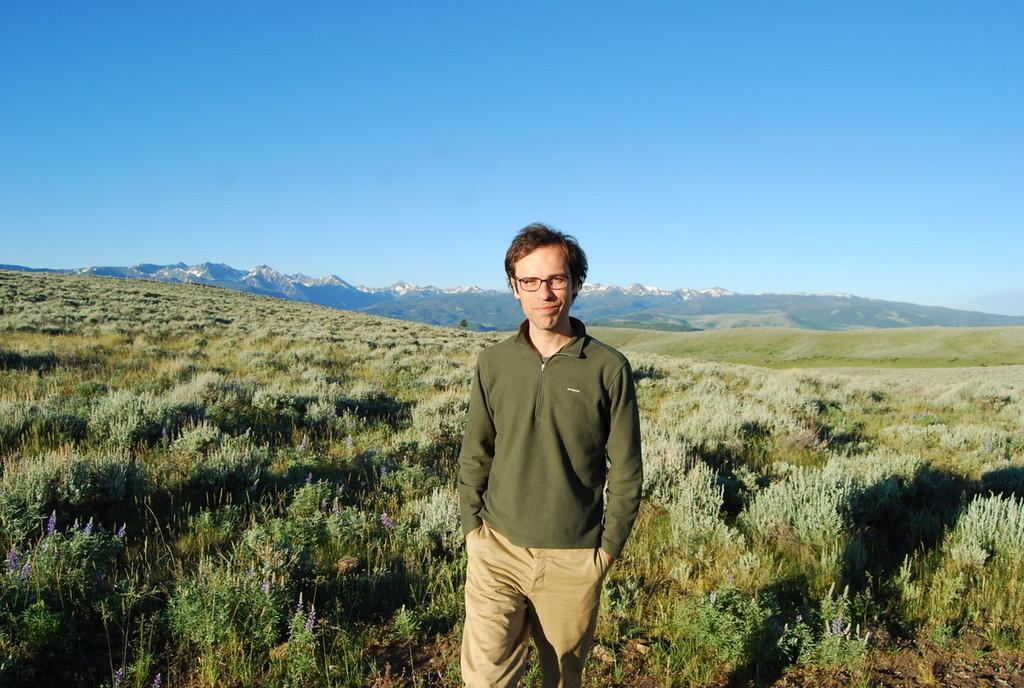Describe this image in one or two sentences. A man is standing wearing clothes, these are plants, this is sky. 